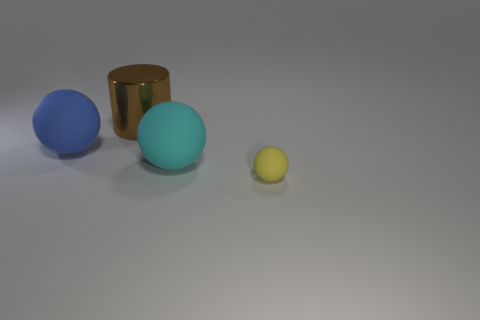Subtract all big balls. How many balls are left? 1 Add 4 tiny balls. How many objects exist? 8 Subtract all cyan balls. How many balls are left? 2 Subtract all cylinders. How many objects are left? 3 Subtract 1 spheres. How many spheres are left? 2 Subtract 0 gray blocks. How many objects are left? 4 Subtract all gray spheres. Subtract all yellow cylinders. How many spheres are left? 3 Subtract all large green matte cylinders. Subtract all yellow rubber spheres. How many objects are left? 3 Add 1 blue spheres. How many blue spheres are left? 2 Add 2 big balls. How many big balls exist? 4 